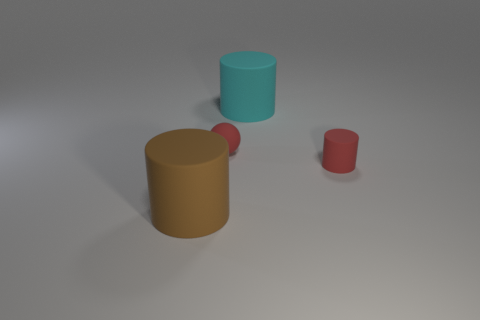What shape is the matte object that is to the right of the brown matte thing and in front of the tiny rubber ball?
Provide a succinct answer. Cylinder. What color is the rubber thing in front of the red rubber cylinder?
Make the answer very short. Brown. What is the size of the cylinder that is on the left side of the red cylinder and in front of the cyan matte cylinder?
Your response must be concise. Large. Are the small red cylinder and the large cylinder that is behind the brown rubber thing made of the same material?
Provide a short and direct response. Yes. How many tiny red matte objects are the same shape as the brown object?
Provide a succinct answer. 1. How many brown rubber cylinders are there?
Your answer should be compact. 1. Do the large brown rubber object and the tiny red thing that is to the left of the big cyan matte cylinder have the same shape?
Make the answer very short. No. What number of objects are tiny yellow cylinders or red things on the right side of the big cyan cylinder?
Keep it short and to the point. 1. Does the red matte thing that is behind the tiny cylinder have the same shape as the big brown object?
Provide a short and direct response. No. Are there fewer small cylinders that are behind the small red rubber ball than tiny red things that are to the left of the big cyan matte cylinder?
Offer a very short reply. Yes. 